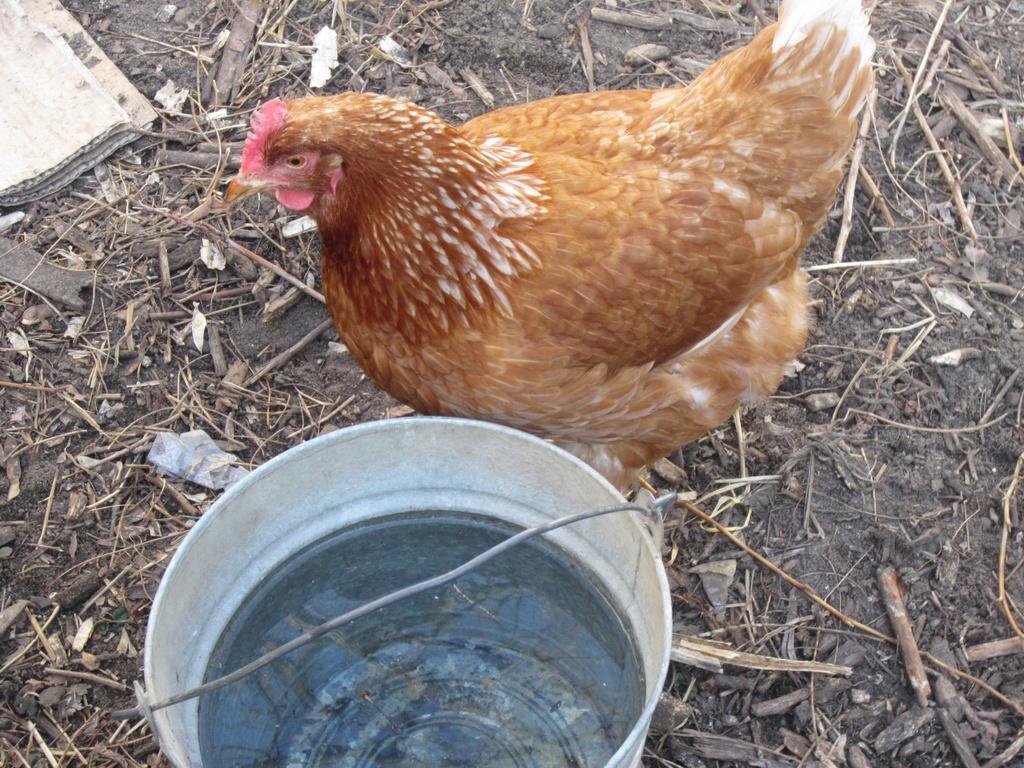Describe this image in one or two sentences. In this image we can see hen which is in brown color, there is a bucket in which there is water and we can see cardboard sheet on left side of the image. 